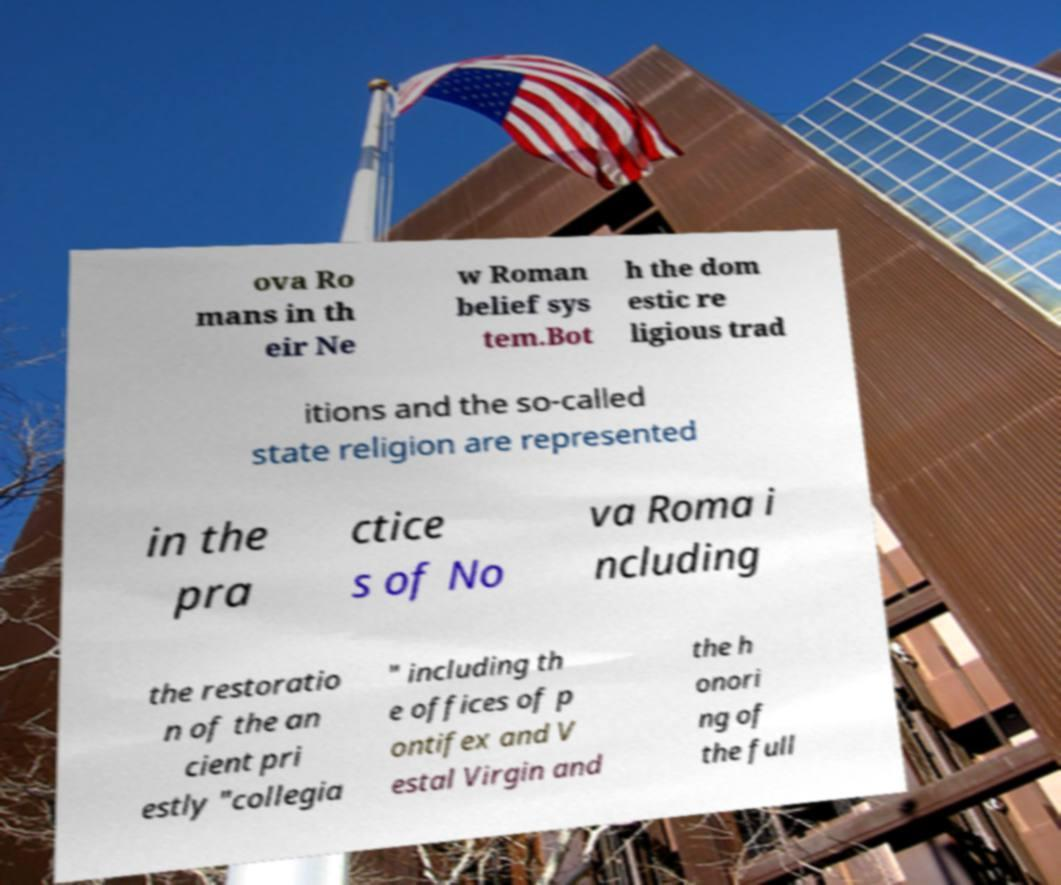Can you accurately transcribe the text from the provided image for me? ova Ro mans in th eir Ne w Roman belief sys tem.Bot h the dom estic re ligious trad itions and the so-called state religion are represented in the pra ctice s of No va Roma i ncluding the restoratio n of the an cient pri estly "collegia " including th e offices of p ontifex and V estal Virgin and the h onori ng of the full 